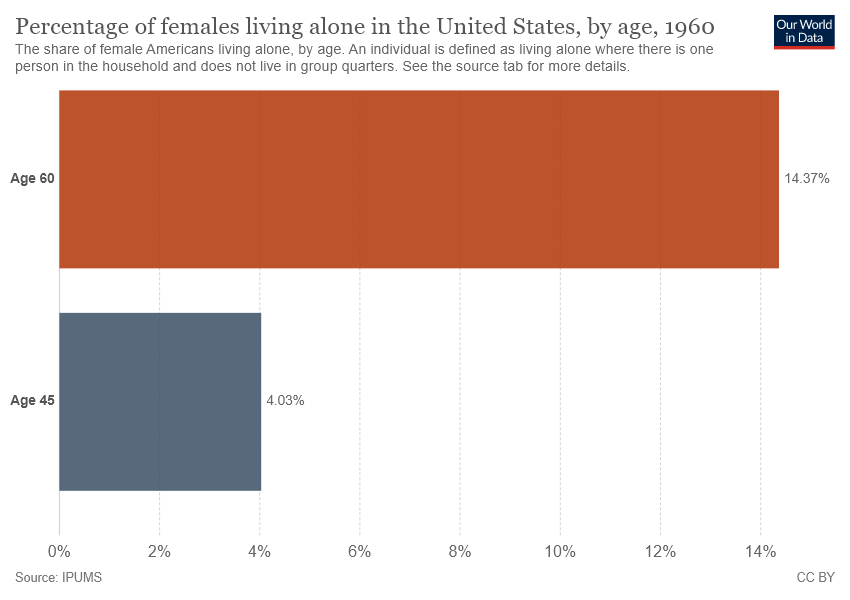Outline some significant characteristics in this image. The sum of the large and small bars is 18.4 points. The large bar has a percentage value of 14.37%. 